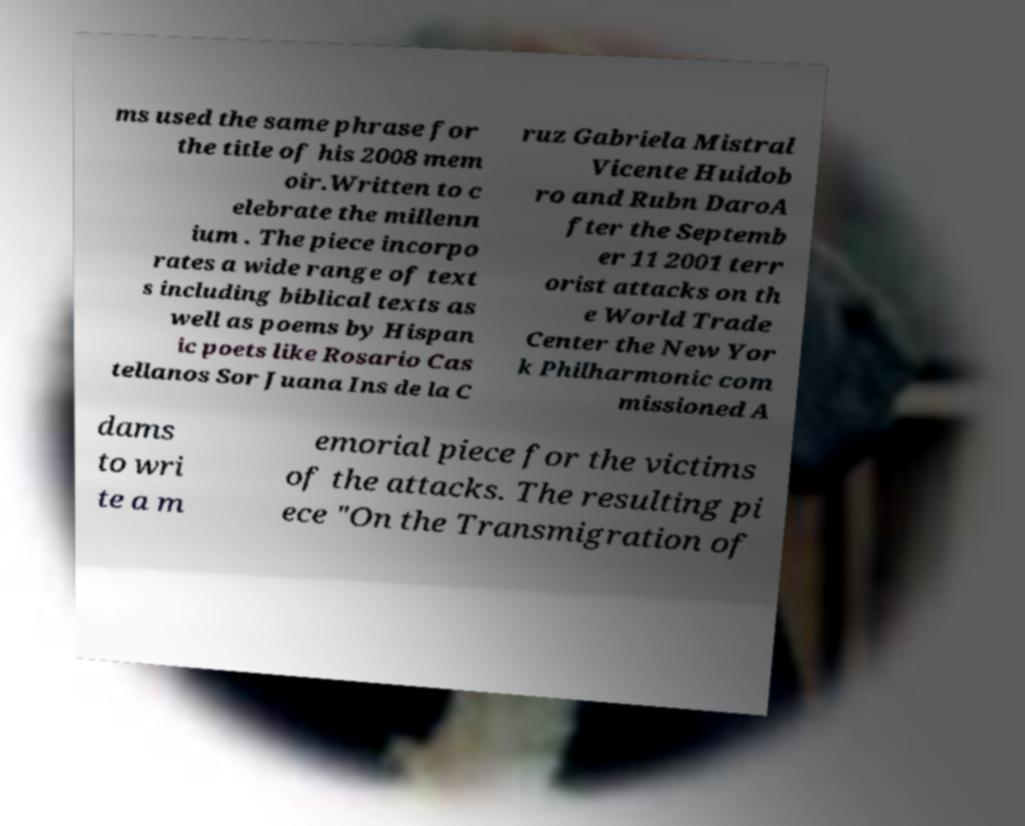I need the written content from this picture converted into text. Can you do that? ms used the same phrase for the title of his 2008 mem oir.Written to c elebrate the millenn ium . The piece incorpo rates a wide range of text s including biblical texts as well as poems by Hispan ic poets like Rosario Cas tellanos Sor Juana Ins de la C ruz Gabriela Mistral Vicente Huidob ro and Rubn DaroA fter the Septemb er 11 2001 terr orist attacks on th e World Trade Center the New Yor k Philharmonic com missioned A dams to wri te a m emorial piece for the victims of the attacks. The resulting pi ece "On the Transmigration of 